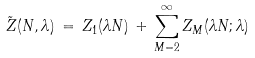<formula> <loc_0><loc_0><loc_500><loc_500>\tilde { Z } ( N , \lambda ) \, = \, Z _ { 1 } ( \lambda N ) \, + \, \sum _ { M = 2 } ^ { \infty } Z _ { M } ( \lambda N ; \lambda )</formula> 